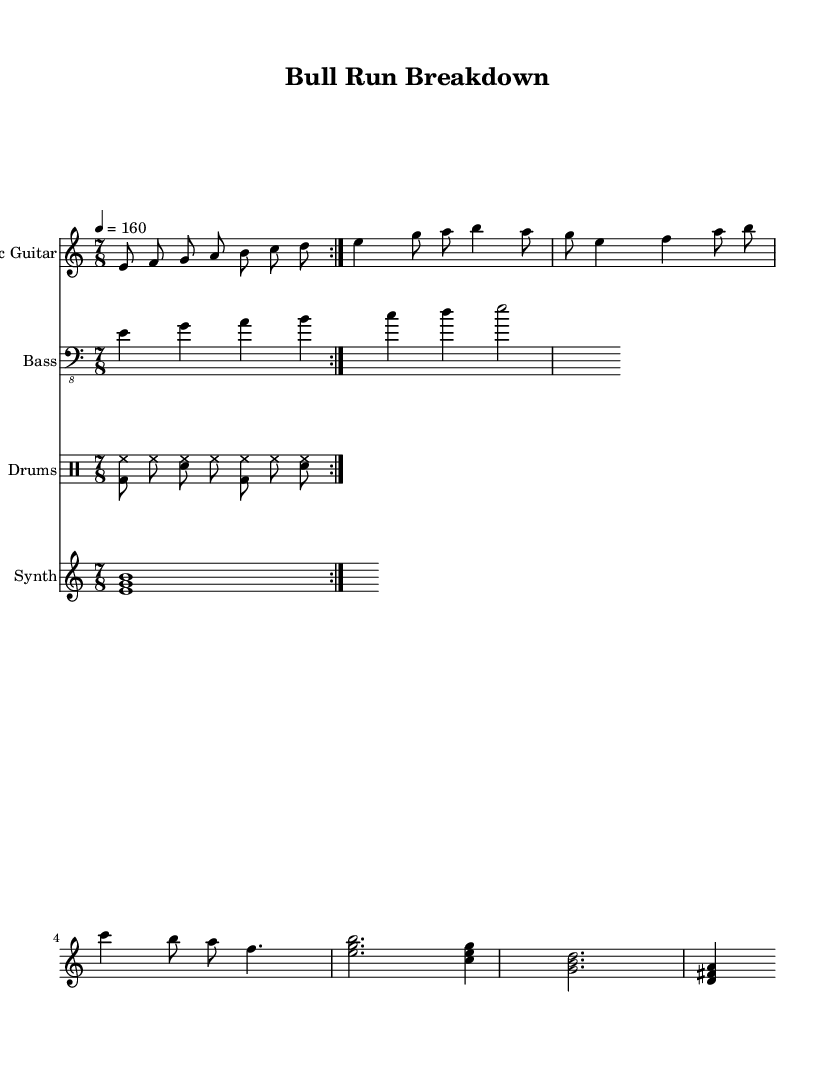What is the key signature of this music? The key signature is E Phrygian, which indicates that the piece is centered around the note E, with the specific characteristic of being a mode that derives from the D major scale and has a flattened second.
Answer: E Phrygian What is the time signature of the piece? The time signature is 7/8, indicating there are seven eighth-note beats in each measure, which contributes to the progressive metal complexity of the rhythm.
Answer: 7/8 What is the tempo marking of the music? The tempo marking is 4 equals 160, which indicates the speed at which the piece should be played, equating to 160 beats per minute.
Answer: 160 What is the structure of the main riff? The main riff is a repeated pattern outlined within the volta, consisting of the notes E, F, G, A, B, C, and D played sequentially in eighth notes.
Answer: E, F, G, A, B, C, D How many bars are in the verse section? The verse section consists of three measures, each containing varying numbers of beats and notes that contribute to the melodic structure.
Answer: 3 Which instruments are included in this sheet music? The sheet music includes Electric Guitar, Bass, Drums, and Synth, creating a full ensemble typical in progressive metal compositions.
Answer: Electric Guitar, Bass, Drums, Synth What is the pattern of the main drum section? The main drum section follows a repetitive pattern that emphasizes the bass drum and snare, typically seen in heavy metal music, creating a driving rhythm.
Answer: <bd hh>8 hh <sn hh> hh <bd hh> hh <sn hh> 